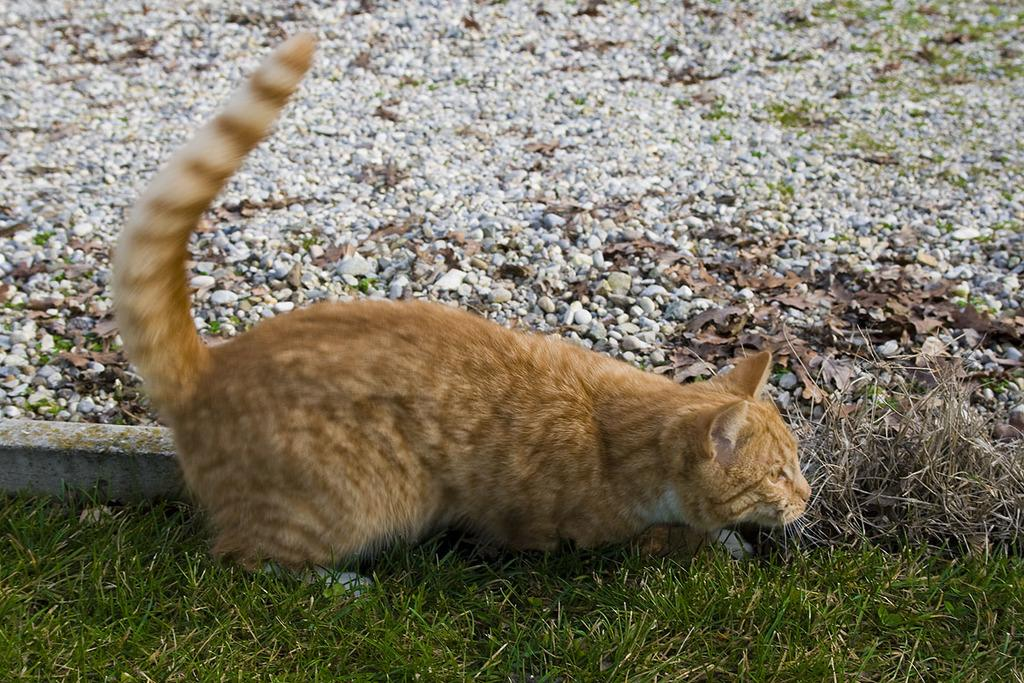What animal is in the middle of the image? There is a cat in the middle of the image. What type of surface is at the bottom of the image? There are stones at the bottom of the image. What type of vegetation is present in the image? There is grass in the image. How many kittens are playing with ink in the image? There are no kittens or ink present in the image. 